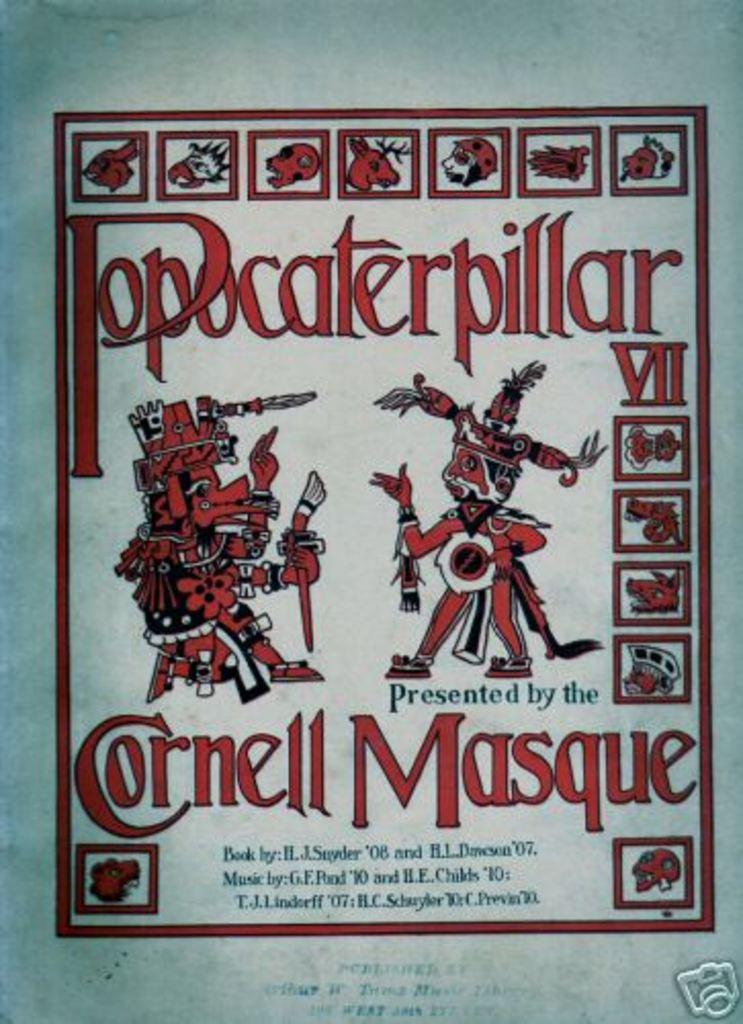What group is presenting popocaterpillar vii?
Provide a short and direct response. Cornell masque. 